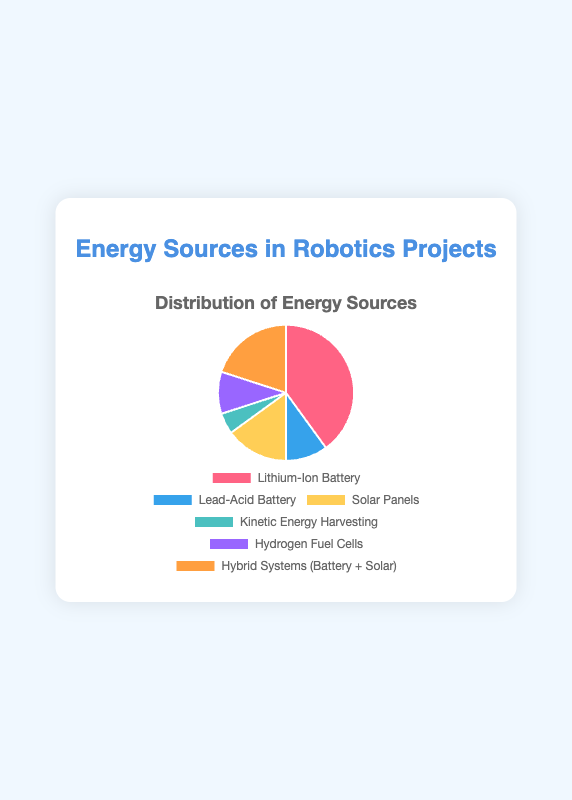what percentage of the energy sources come from batteries? Sum the percentages of Lithium-Ion Battery and Lead-Acid Battery: 40% + 10% = 50%
Answer: 50% Which energy source contributes the least? Identify the energy source with the smallest percentage, which is Kinetic Energy Harvesting at 5%.
Answer: Kinetic Energy Harvesting What is the combined percentage of Solar Panels and Hydrogen Fuel Cells? Sum the percentages of Solar Panels and Hydrogen Fuel Cells: 15% + 10% = 25%
Answer: 25% Which energy source has a higher percentage, Solar Panels or Hybrid Systems (Battery + Solar)? Compare the percentages: Solar Panels (15%) vs Hybrid Systems (Battery + Solar) (20%). Hybrid Systems is higher.
Answer: Hybrid Systems (Battery + Solar) What is the color used to represent Hydrogen Fuel Cells in the pie chart? Refer to the color legend of the pie chart. Hydrogen Fuel Cells are represented by the color purple.
Answer: purple If we were to add a new energy source at 10%, how would the percentages of other sources change relative to 100%? Adding a new source will reduce the shares of existing ones but keep their proportions the same relative to the new total. Each percentage will need to be scaled down to accommodate the new source. Calculations can vary in approach but a rough decrease would be approximately calculated by adjusting for total percentages equaling 110 now.
Answer: Decrease; Exact values vary based on the scaling method used What is the difference in the percentage between the largest and smallest contributors? Subtract the smallest (Kinetic Energy Harvesting: 5%) from the largest (Lithium-Ion Battery: 40%): 40% - 5% = 35%
Answer: 35% Which energy source is represented by the orange color in the chart? Refer to the color legend of the pie chart. Hybrid Systems (Battery + Solar) are represented by the color orange.
Answer: Hybrid Systems (Battery + Solar) How do the combined contributions of Fuel Cells and Lead-Acid Battery compare to Lithium-Ion Battery? Sum the percentages of Hydrogen Fuel Cells and Lead-Acid Battery: 10% + 10% = 20%. Compare this to Lithium-Ion Battery: 40%. Lithium-Ion Battery is notably higher.
Answer: Lithium-Ion Battery > Fuel Cells + Lead-Acid Battery What percentage of energy sources come from non-renewable options (batteries only)? Identify and sum the percentages of non-renewable energy sources, which are Lithium-Ion Battery (40%) and Lead-Acid Battery (10%): 40% + 10% = 50%
Answer: 50% 